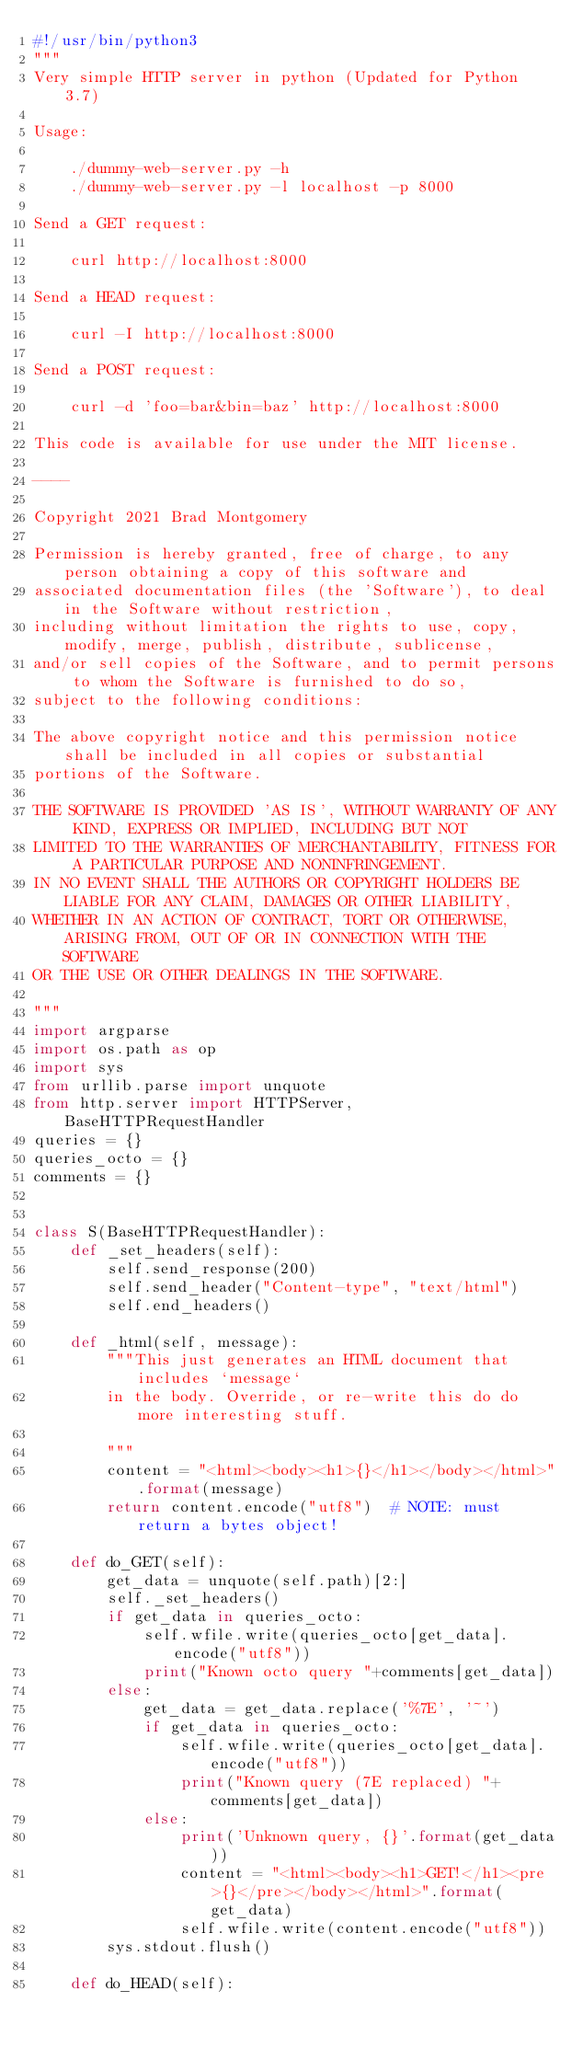<code> <loc_0><loc_0><loc_500><loc_500><_Python_>#!/usr/bin/python3
"""
Very simple HTTP server in python (Updated for Python 3.7)

Usage:

    ./dummy-web-server.py -h
    ./dummy-web-server.py -l localhost -p 8000

Send a GET request:

    curl http://localhost:8000

Send a HEAD request:

    curl -I http://localhost:8000

Send a POST request:

    curl -d 'foo=bar&bin=baz' http://localhost:8000

This code is available for use under the MIT license.

----

Copyright 2021 Brad Montgomery

Permission is hereby granted, free of charge, to any person obtaining a copy of this software and
associated documentation files (the 'Software'), to deal in the Software without restriction,
including without limitation the rights to use, copy, modify, merge, publish, distribute, sublicense,
and/or sell copies of the Software, and to permit persons to whom the Software is furnished to do so,
subject to the following conditions:

The above copyright notice and this permission notice shall be included in all copies or substantial
portions of the Software.

THE SOFTWARE IS PROVIDED 'AS IS', WITHOUT WARRANTY OF ANY KIND, EXPRESS OR IMPLIED, INCLUDING BUT NOT
LIMITED TO THE WARRANTIES OF MERCHANTABILITY, FITNESS FOR A PARTICULAR PURPOSE AND NONINFRINGEMENT.
IN NO EVENT SHALL THE AUTHORS OR COPYRIGHT HOLDERS BE LIABLE FOR ANY CLAIM, DAMAGES OR OTHER LIABILITY,
WHETHER IN AN ACTION OF CONTRACT, TORT OR OTHERWISE, ARISING FROM, OUT OF OR IN CONNECTION WITH THE SOFTWARE
OR THE USE OR OTHER DEALINGS IN THE SOFTWARE.

"""
import argparse
import os.path as op
import sys
from urllib.parse import unquote
from http.server import HTTPServer, BaseHTTPRequestHandler
queries = {}
queries_octo = {}
comments = {}


class S(BaseHTTPRequestHandler):
    def _set_headers(self):
        self.send_response(200)
        self.send_header("Content-type", "text/html")
        self.end_headers()

    def _html(self, message):
        """This just generates an HTML document that includes `message`
        in the body. Override, or re-write this do do more interesting stuff.

        """
        content = "<html><body><h1>{}</h1></body></html>".format(message)
        return content.encode("utf8")  # NOTE: must return a bytes object!

    def do_GET(self):
        get_data = unquote(self.path)[2:]
        self._set_headers()
        if get_data in queries_octo:
            self.wfile.write(queries_octo[get_data].encode("utf8"))
            print("Known octo query "+comments[get_data])
        else:
            get_data = get_data.replace('%7E', '~')
            if get_data in queries_octo:
                self.wfile.write(queries_octo[get_data].encode("utf8"))
                print("Known query (7E replaced) "+comments[get_data])
            else:
                print('Unknown query, {}'.format(get_data))
                content = "<html><body><h1>GET!</h1><pre>{}</pre></body></html>".format(get_data)
                self.wfile.write(content.encode("utf8"))
        sys.stdout.flush()

    def do_HEAD(self):</code> 